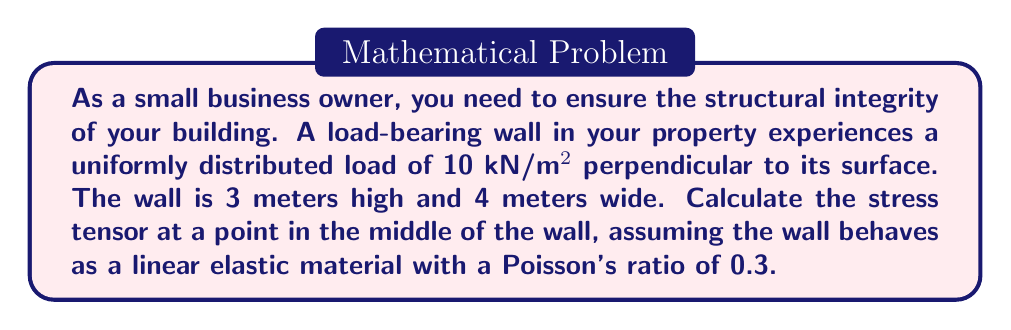Give your solution to this math problem. To calculate the stress tensor for the load-bearing wall, we'll follow these steps:

1. Identify the stress components:
   The primary stress will be normal stress (σ) perpendicular to the wall surface. We'll assume this is in the x-direction. Due to Poisson's effect, there will be lateral stresses in the y and z directions.

2. Calculate the normal stress (σ_x):
   $\sigma_x = \frac{Force}{Area} = \frac{10 \text{ kN/m²} \cdot (3\text{ m} \cdot 4\text{ m})}{3\text{ m} \cdot 4\text{ m}} = 10 \text{ kN/m²} = 10 \text{ kPa}$

3. Calculate the lateral stresses using Poisson's ratio (ν = 0.3):
   $\sigma_y = \sigma_z = -\nu \sigma_x = -0.3 \cdot 10 \text{ kPa} = -3 \text{ kPa}$

4. Assume no shear stresses due to uniform loading:
   $\tau_{xy} = \tau_{yz} = \tau_{xz} = 0$

5. Construct the stress tensor:
   $$\sigma_{ij} = \begin{bmatrix}
   \sigma_x & \tau_{xy} & \tau_{xz} \\
   \tau_{xy} & \sigma_y & \tau_{yz} \\
   \tau_{xz} & \tau_{yz} & \sigma_z
   \end{bmatrix} = \begin{bmatrix}
   10 & 0 & 0 \\
   0 & -3 & 0 \\
   0 & 0 & -3
   \end{bmatrix} \text{ kPa}$$
Answer: $$\sigma_{ij} = \begin{bmatrix}
10 & 0 & 0 \\
0 & -3 & 0 \\
0 & 0 & -3
\end{bmatrix} \text{ kPa}$$ 